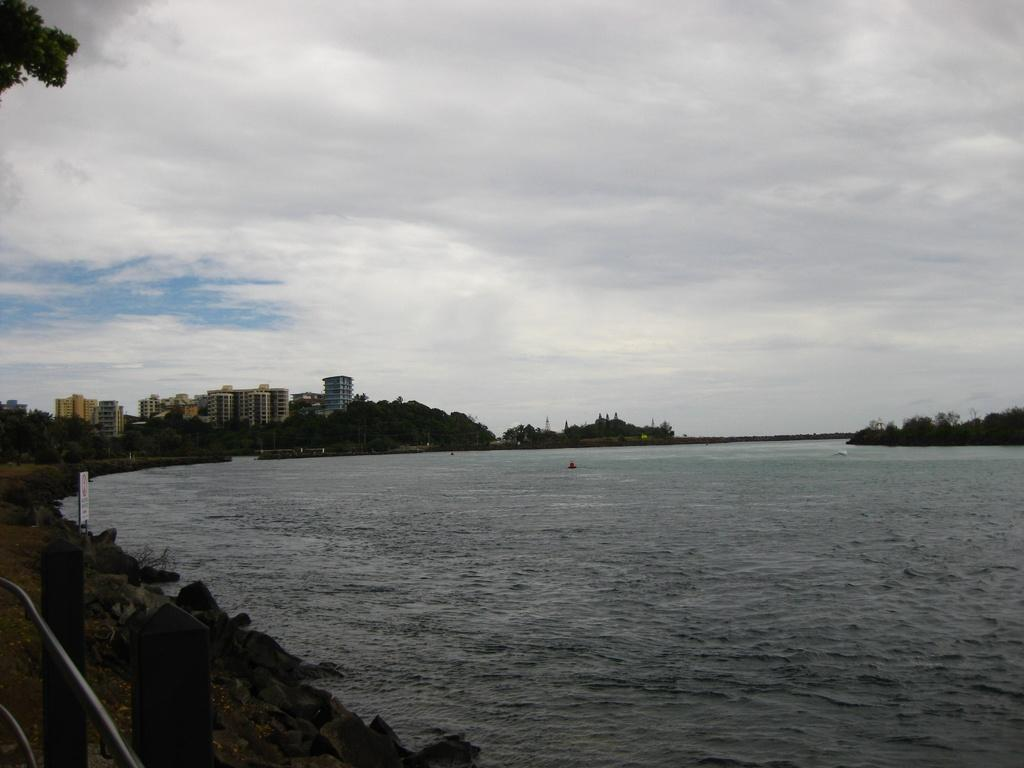What is the primary element visible in the image? There is water in the image. What can be seen in the background of the image? There are trees and buildings in the background of the image. How would you describe the sky in the image? The sky is cloudy at the top of the image. What is your sister's reaction to the water in the image? There is no mention of a sister or any reaction in the image, so it cannot be determined from the image. 